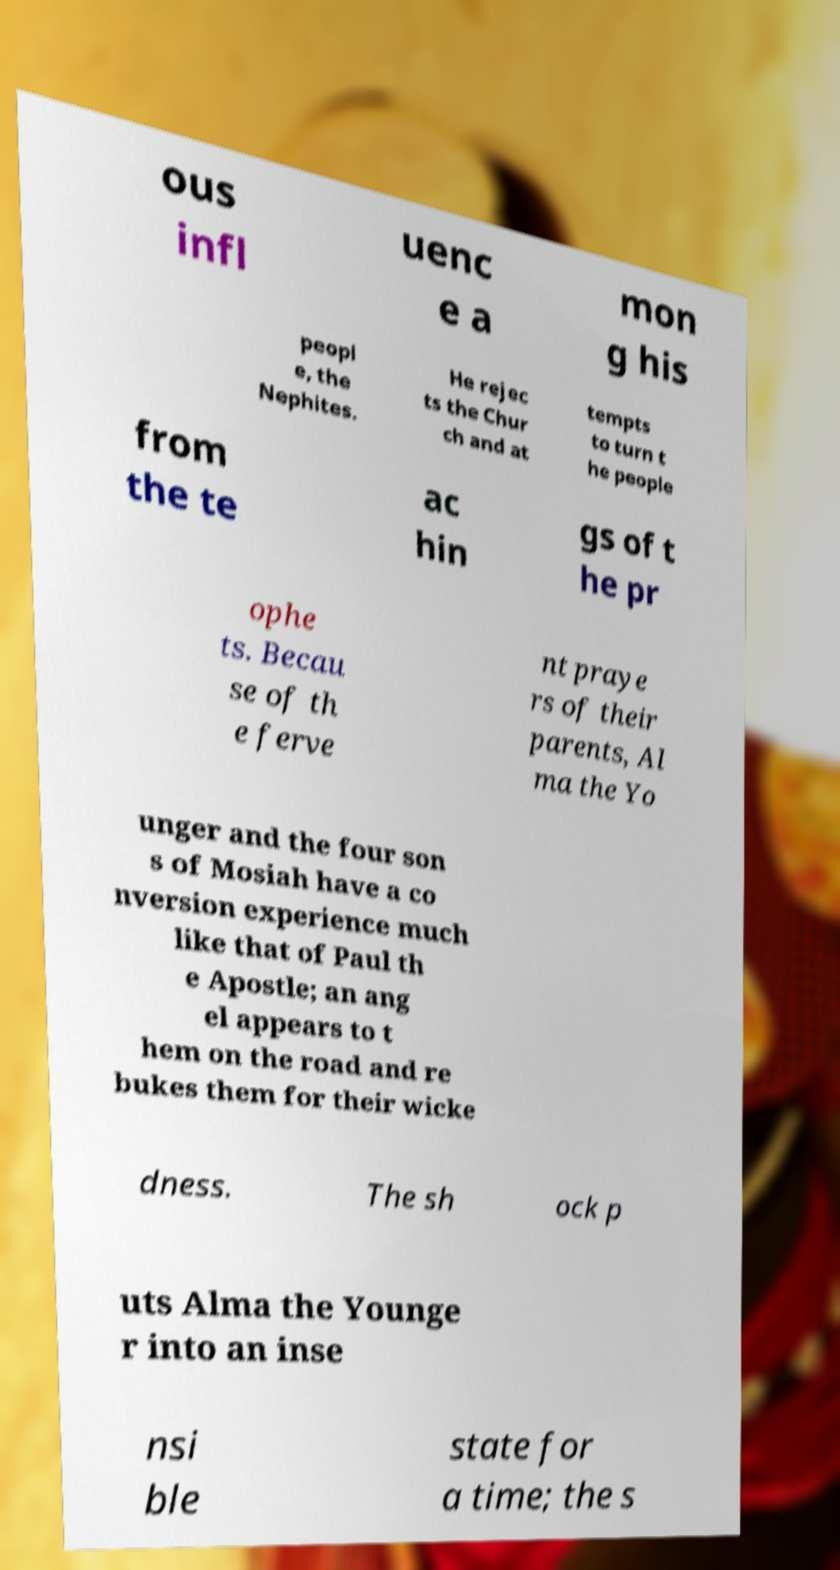I need the written content from this picture converted into text. Can you do that? ous infl uenc e a mon g his peopl e, the Nephites. He rejec ts the Chur ch and at tempts to turn t he people from the te ac hin gs of t he pr ophe ts. Becau se of th e ferve nt praye rs of their parents, Al ma the Yo unger and the four son s of Mosiah have a co nversion experience much like that of Paul th e Apostle; an ang el appears to t hem on the road and re bukes them for their wicke dness. The sh ock p uts Alma the Younge r into an inse nsi ble state for a time; the s 